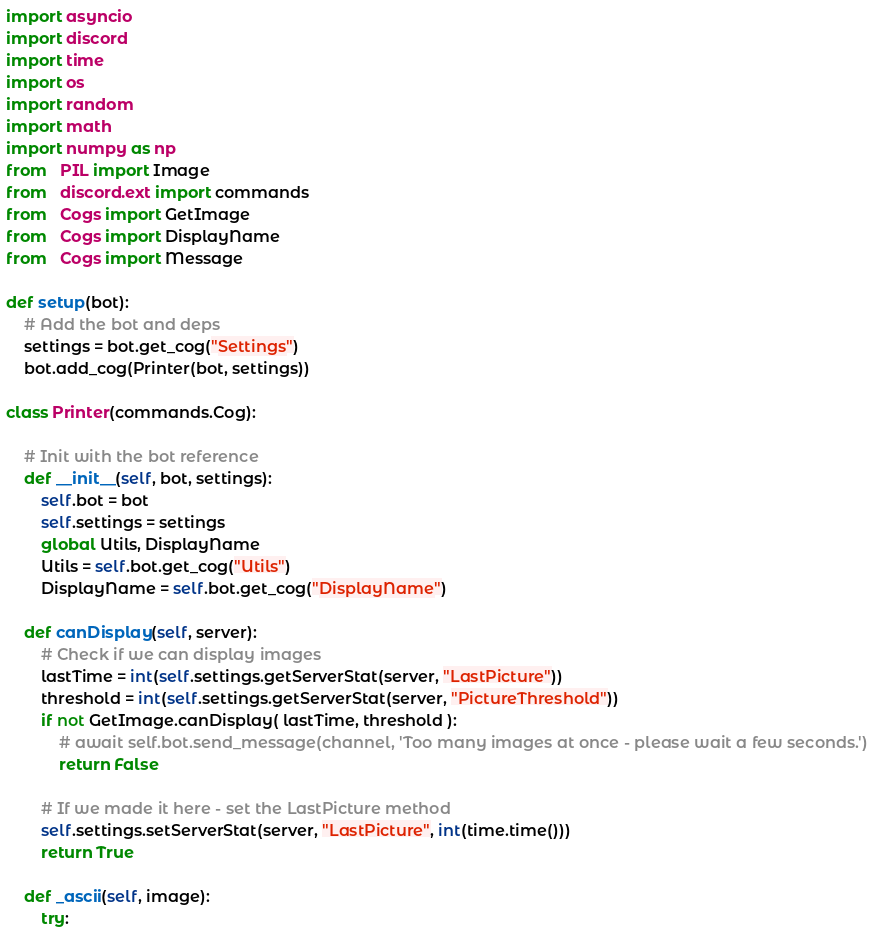<code> <loc_0><loc_0><loc_500><loc_500><_Python_>import asyncio
import discord
import time
import os
import random
import math
import numpy as np
from   PIL import Image
from   discord.ext import commands
from   Cogs import GetImage
from   Cogs import DisplayName
from   Cogs import Message

def setup(bot):
	# Add the bot and deps
	settings = bot.get_cog("Settings")
	bot.add_cog(Printer(bot, settings))

class Printer(commands.Cog):

	# Init with the bot reference
	def __init__(self, bot, settings):
		self.bot = bot
		self.settings = settings
		global Utils, DisplayName
		Utils = self.bot.get_cog("Utils")
		DisplayName = self.bot.get_cog("DisplayName")

	def canDisplay(self, server):
		# Check if we can display images
		lastTime = int(self.settings.getServerStat(server, "LastPicture"))
		threshold = int(self.settings.getServerStat(server, "PictureThreshold"))
		if not GetImage.canDisplay( lastTime, threshold ):
			# await self.bot.send_message(channel, 'Too many images at once - please wait a few seconds.')
			return False
		
		# If we made it here - set the LastPicture method
		self.settings.setServerStat(server, "LastPicture", int(time.time()))
		return True

	def _ascii(self, image):
		try:</code> 